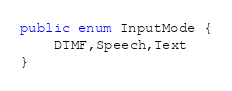<code> <loc_0><loc_0><loc_500><loc_500><_Java_>
public enum InputMode {
    DTMF,Speech,Text
}
</code> 